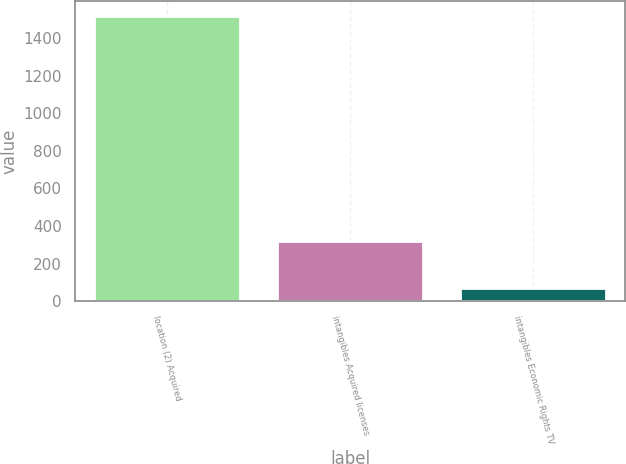Convert chart to OTSL. <chart><loc_0><loc_0><loc_500><loc_500><bar_chart><fcel>location (2) Acquired<fcel>intangibles Acquired licenses<fcel>intangibles Economic Rights TV<nl><fcel>1520<fcel>320<fcel>70<nl></chart> 